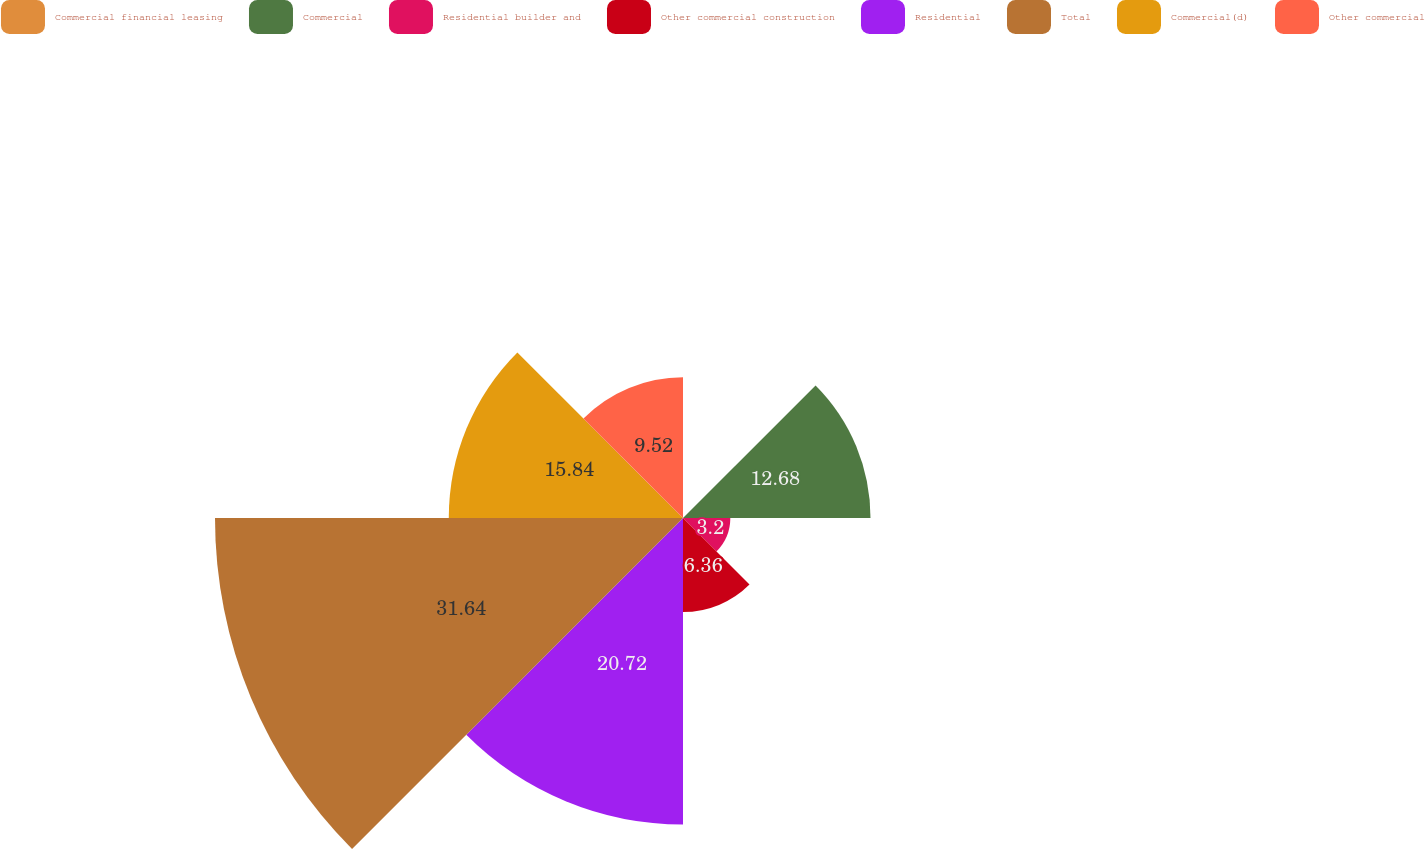<chart> <loc_0><loc_0><loc_500><loc_500><pie_chart><fcel>Commercial financial leasing<fcel>Commercial<fcel>Residential builder and<fcel>Other commercial construction<fcel>Residential<fcel>Total<fcel>Commercial(d)<fcel>Other commercial<nl><fcel>0.04%<fcel>12.68%<fcel>3.2%<fcel>6.36%<fcel>20.73%<fcel>31.65%<fcel>15.84%<fcel>9.52%<nl></chart> 